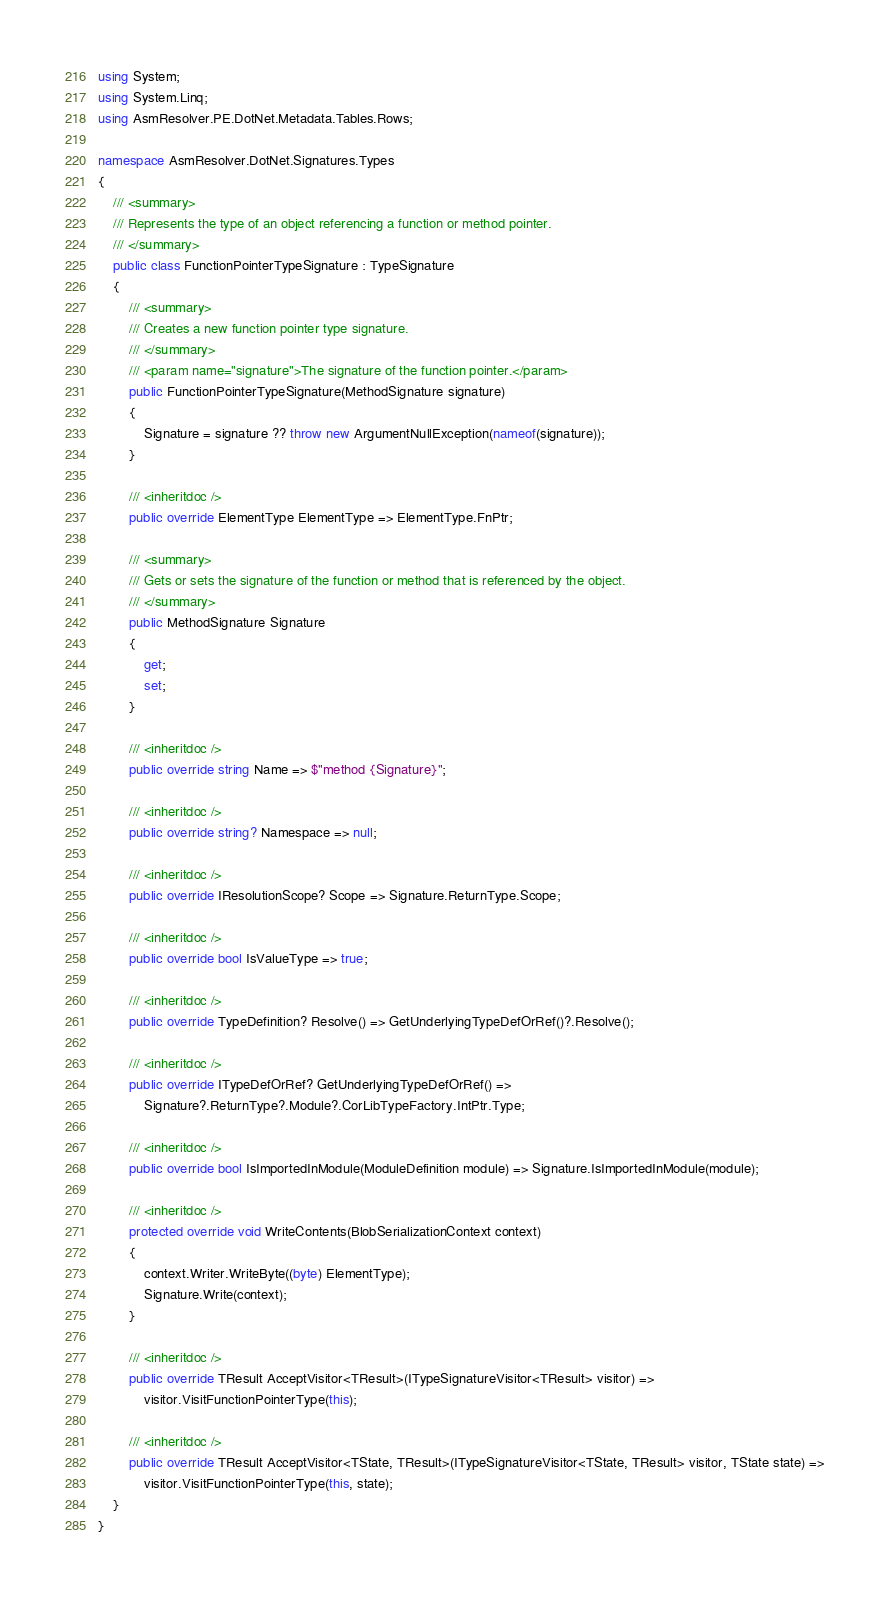<code> <loc_0><loc_0><loc_500><loc_500><_C#_>using System;
using System.Linq;
using AsmResolver.PE.DotNet.Metadata.Tables.Rows;

namespace AsmResolver.DotNet.Signatures.Types
{
    /// <summary>
    /// Represents the type of an object referencing a function or method pointer.
    /// </summary>
    public class FunctionPointerTypeSignature : TypeSignature
    {
        /// <summary>
        /// Creates a new function pointer type signature.
        /// </summary>
        /// <param name="signature">The signature of the function pointer.</param>
        public FunctionPointerTypeSignature(MethodSignature signature)
        {
            Signature = signature ?? throw new ArgumentNullException(nameof(signature));
        }

        /// <inheritdoc />
        public override ElementType ElementType => ElementType.FnPtr;

        /// <summary>
        /// Gets or sets the signature of the function or method that is referenced by the object.
        /// </summary>
        public MethodSignature Signature
        {
            get;
            set;
        }

        /// <inheritdoc />
        public override string Name => $"method {Signature}";

        /// <inheritdoc />
        public override string? Namespace => null;

        /// <inheritdoc />
        public override IResolutionScope? Scope => Signature.ReturnType.Scope;

        /// <inheritdoc />
        public override bool IsValueType => true;

        /// <inheritdoc />
        public override TypeDefinition? Resolve() => GetUnderlyingTypeDefOrRef()?.Resolve();

        /// <inheritdoc />
        public override ITypeDefOrRef? GetUnderlyingTypeDefOrRef() =>
            Signature?.ReturnType?.Module?.CorLibTypeFactory.IntPtr.Type;

        /// <inheritdoc />
        public override bool IsImportedInModule(ModuleDefinition module) => Signature.IsImportedInModule(module);

        /// <inheritdoc />
        protected override void WriteContents(BlobSerializationContext context)
        {
            context.Writer.WriteByte((byte) ElementType);
            Signature.Write(context);
        }

        /// <inheritdoc />
        public override TResult AcceptVisitor<TResult>(ITypeSignatureVisitor<TResult> visitor) =>
            visitor.VisitFunctionPointerType(this);

        /// <inheritdoc />
        public override TResult AcceptVisitor<TState, TResult>(ITypeSignatureVisitor<TState, TResult> visitor, TState state) =>
            visitor.VisitFunctionPointerType(this, state);
    }
}
</code> 